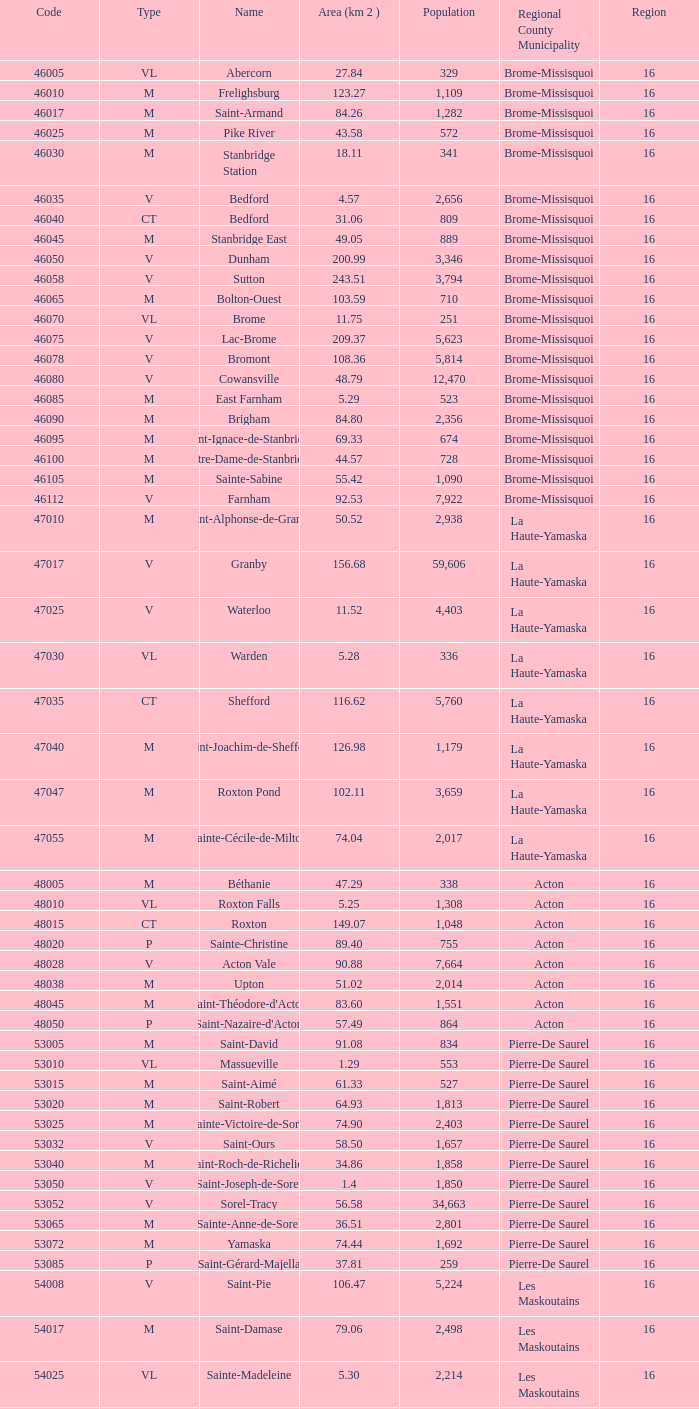What is the code for a Le Haut-Saint-Laurent municipality that has 16 or more regions? None. 